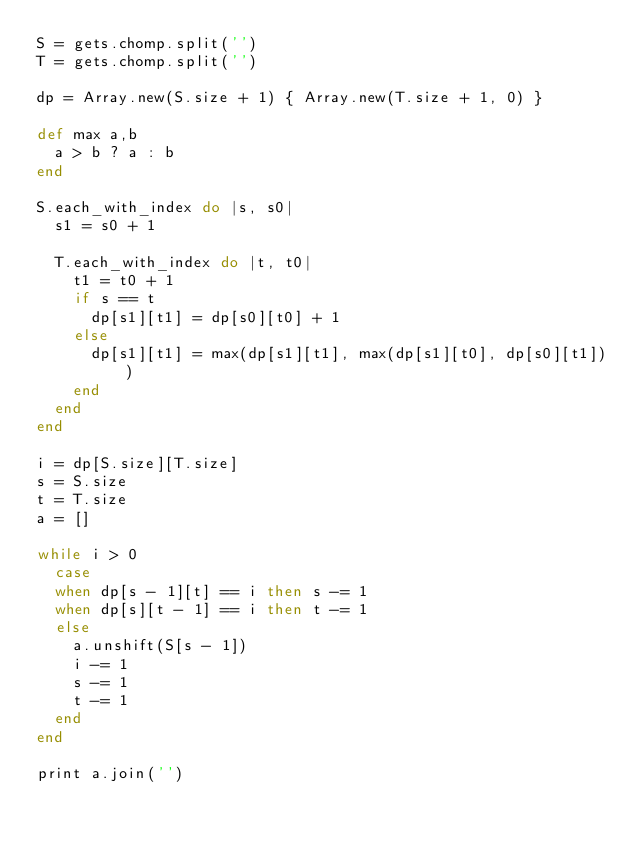<code> <loc_0><loc_0><loc_500><loc_500><_Ruby_>S = gets.chomp.split('')
T = gets.chomp.split('')

dp = Array.new(S.size + 1) { Array.new(T.size + 1, 0) }

def max a,b
  a > b ? a : b
end

S.each_with_index do |s, s0|
  s1 = s0 + 1

  T.each_with_index do |t, t0|
    t1 = t0 + 1
    if s == t 
      dp[s1][t1] = dp[s0][t0] + 1
    else
      dp[s1][t1] = max(dp[s1][t1], max(dp[s1][t0], dp[s0][t1]))
    end
  end
end

i = dp[S.size][T.size]
s = S.size
t = T.size
a = []

while i > 0
  case
  when dp[s - 1][t] == i then s -= 1
  when dp[s][t - 1] == i then t -= 1
  else
    a.unshift(S[s - 1])
    i -= 1
    s -= 1
    t -= 1
  end
end

print a.join('')</code> 